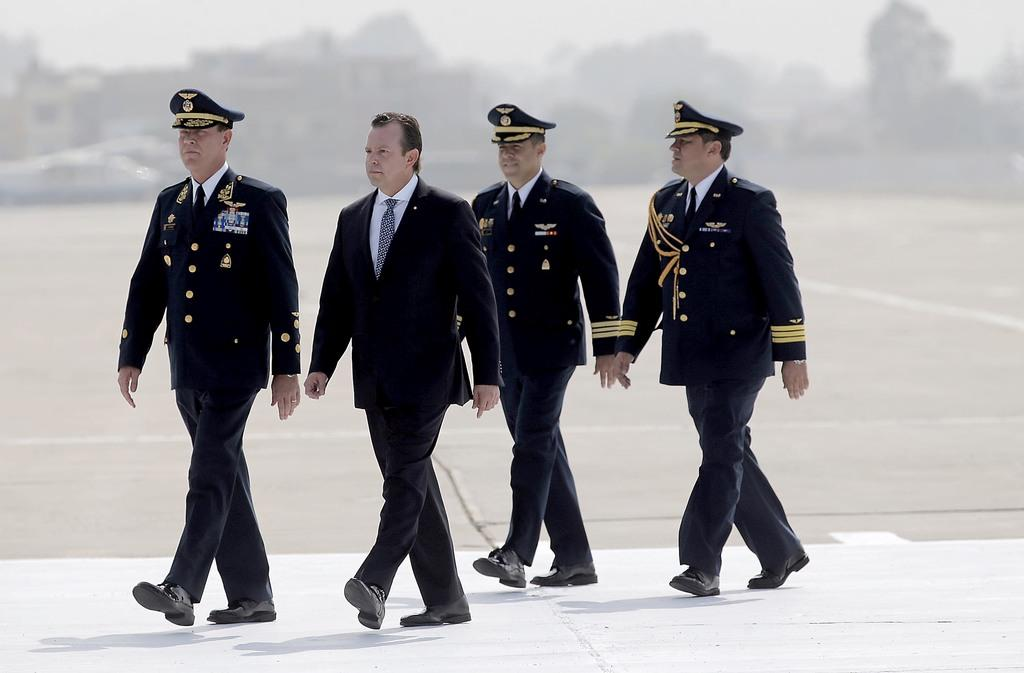How many people are in the image? There are four persons in the image. What are the persons doing in the image? The persons are walking on a path. Can you describe the background of the image? The background of the image has a blurred view. How many beds can be seen in the image? There are no beds present in the image. What type of work are the persons engaged in while walking in the image? The image does not show the persons engaged in any work while walking. 